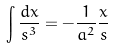Convert formula to latex. <formula><loc_0><loc_0><loc_500><loc_500>\int \frac { d x } { s ^ { 3 } } = - \frac { 1 } { a ^ { 2 } } \frac { x } { s }</formula> 